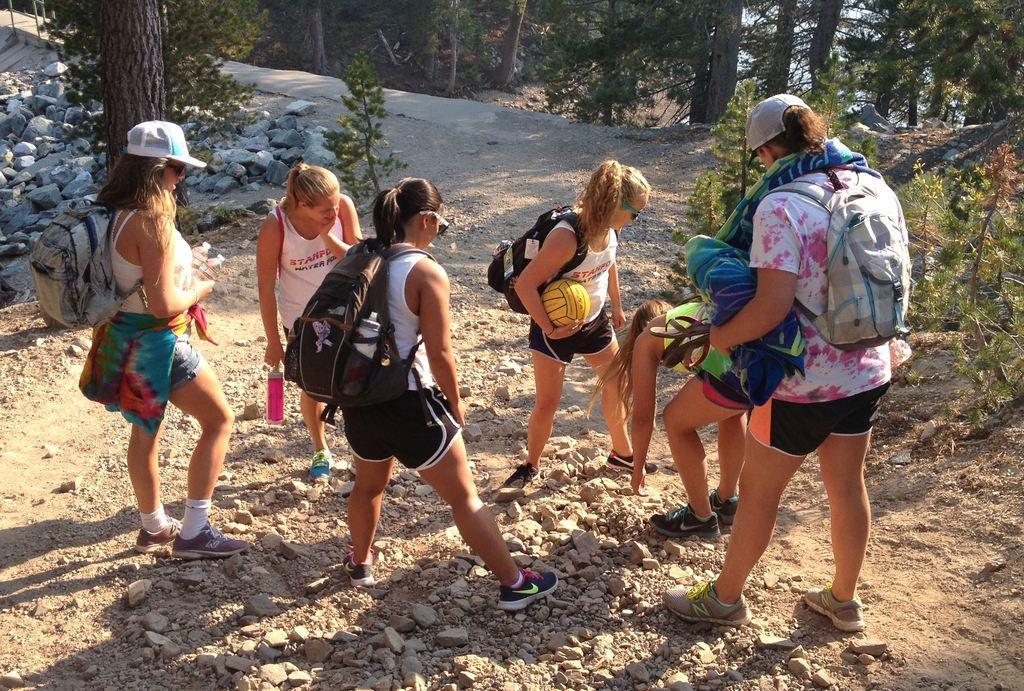In one or two sentences, can you explain what this image depicts? In this image there are groups of women standing, they are wearing bags, they are holding an object, there are plants towards the right of the image, there are trees towards the top of the image, there are rocks towards the left of the image, there is a ground towards the bottom of the image, there are stones on the ground. 